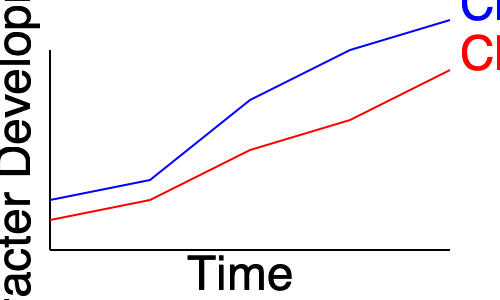Analyze the character development arcs depicted in the line graph. Which character undergoes a more significant transformation throughout the story, and what literary techniques might an author employ to achieve this contrast in character growth? 1. Observe the starting points: Both characters begin at relatively high points on the y-axis, indicating they start with some level of development.

2. Compare the slopes: 
   - Character A (blue line) has a steeper downward slope, indicating rapid change.
   - Character B (red line) has a more gradual slope, suggesting slower, steady development.

3. Analyze the end points: 
   - Character A ends at a much lower point than where they started.
   - Character B also ends lower but not as dramatically as Character A.

4. Interpret the graph:
   - Character A's arc suggests a more drastic transformation or "fall from grace."
   - Character B's arc indicates a more subtle, gradual change.

5. Literary techniques to achieve this contrast:
   - For Character A: Use of dramatic events, internal conflicts, or pivotal moments that drastically alter their perspective or situation.
   - For Character B: Employ subtle character interactions, gradual realizations, or a series of smaller events that accumulate to create change.

6. Additional techniques:
   - Juxtaposition of the characters' experiences
   - Varying narrative focus between characters
   - Use of different narrative voices or perspectives

7. Conclusion: Character A undergoes a more significant transformation, as evidenced by the steeper slope and greater overall change from beginning to end.
Answer: Character A; techniques include dramatic events, internal conflicts, juxtaposition, and varying narrative focus. 